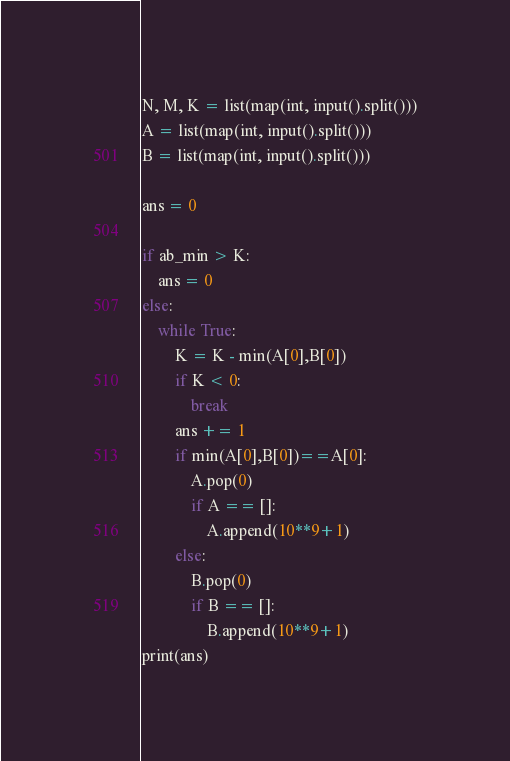<code> <loc_0><loc_0><loc_500><loc_500><_Python_>N, M, K = list(map(int, input().split()))
A = list(map(int, input().split()))
B = list(map(int, input().split()))

ans = 0

if ab_min > K:
    ans = 0
else:
    while True:
        K = K - min(A[0],B[0])
        if K < 0:
            break
        ans += 1
        if min(A[0],B[0])==A[0]:
            A.pop(0)
            if A == []:
                A.append(10**9+1)
        else:
            B.pop(0)
            if B == []:
                B.append(10**9+1)
print(ans)</code> 